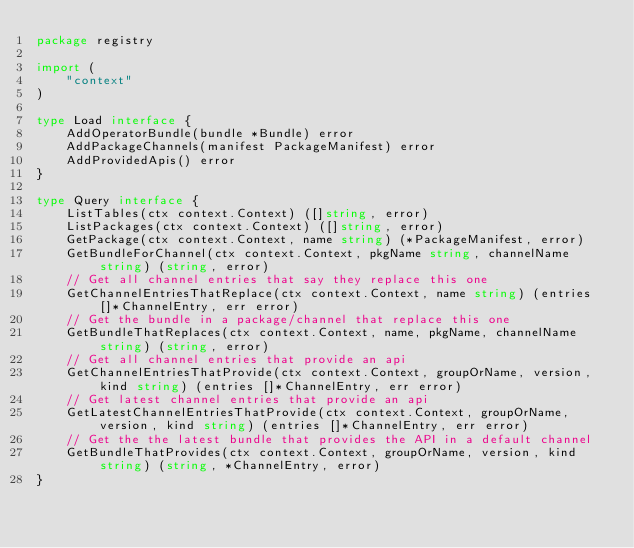<code> <loc_0><loc_0><loc_500><loc_500><_Go_>package registry

import (
	"context"
)

type Load interface {
	AddOperatorBundle(bundle *Bundle) error
	AddPackageChannels(manifest PackageManifest) error
	AddProvidedApis() error
}

type Query interface {
	ListTables(ctx context.Context) ([]string, error)
	ListPackages(ctx context.Context) ([]string, error)
	GetPackage(ctx context.Context, name string) (*PackageManifest, error)
	GetBundleForChannel(ctx context.Context, pkgName string, channelName string) (string, error)
	// Get all channel entries that say they replace this one
	GetChannelEntriesThatReplace(ctx context.Context, name string) (entries []*ChannelEntry, err error)
	// Get the bundle in a package/channel that replace this one
	GetBundleThatReplaces(ctx context.Context, name, pkgName, channelName string) (string, error)
	// Get all channel entries that provide an api
	GetChannelEntriesThatProvide(ctx context.Context, groupOrName, version, kind string) (entries []*ChannelEntry, err error)
	// Get latest channel entries that provide an api
	GetLatestChannelEntriesThatProvide(ctx context.Context, groupOrName, version, kind string) (entries []*ChannelEntry, err error)
	// Get the the latest bundle that provides the API in a default channel
	GetBundleThatProvides(ctx context.Context, groupOrName, version, kind string) (string, *ChannelEntry, error)
}
</code> 